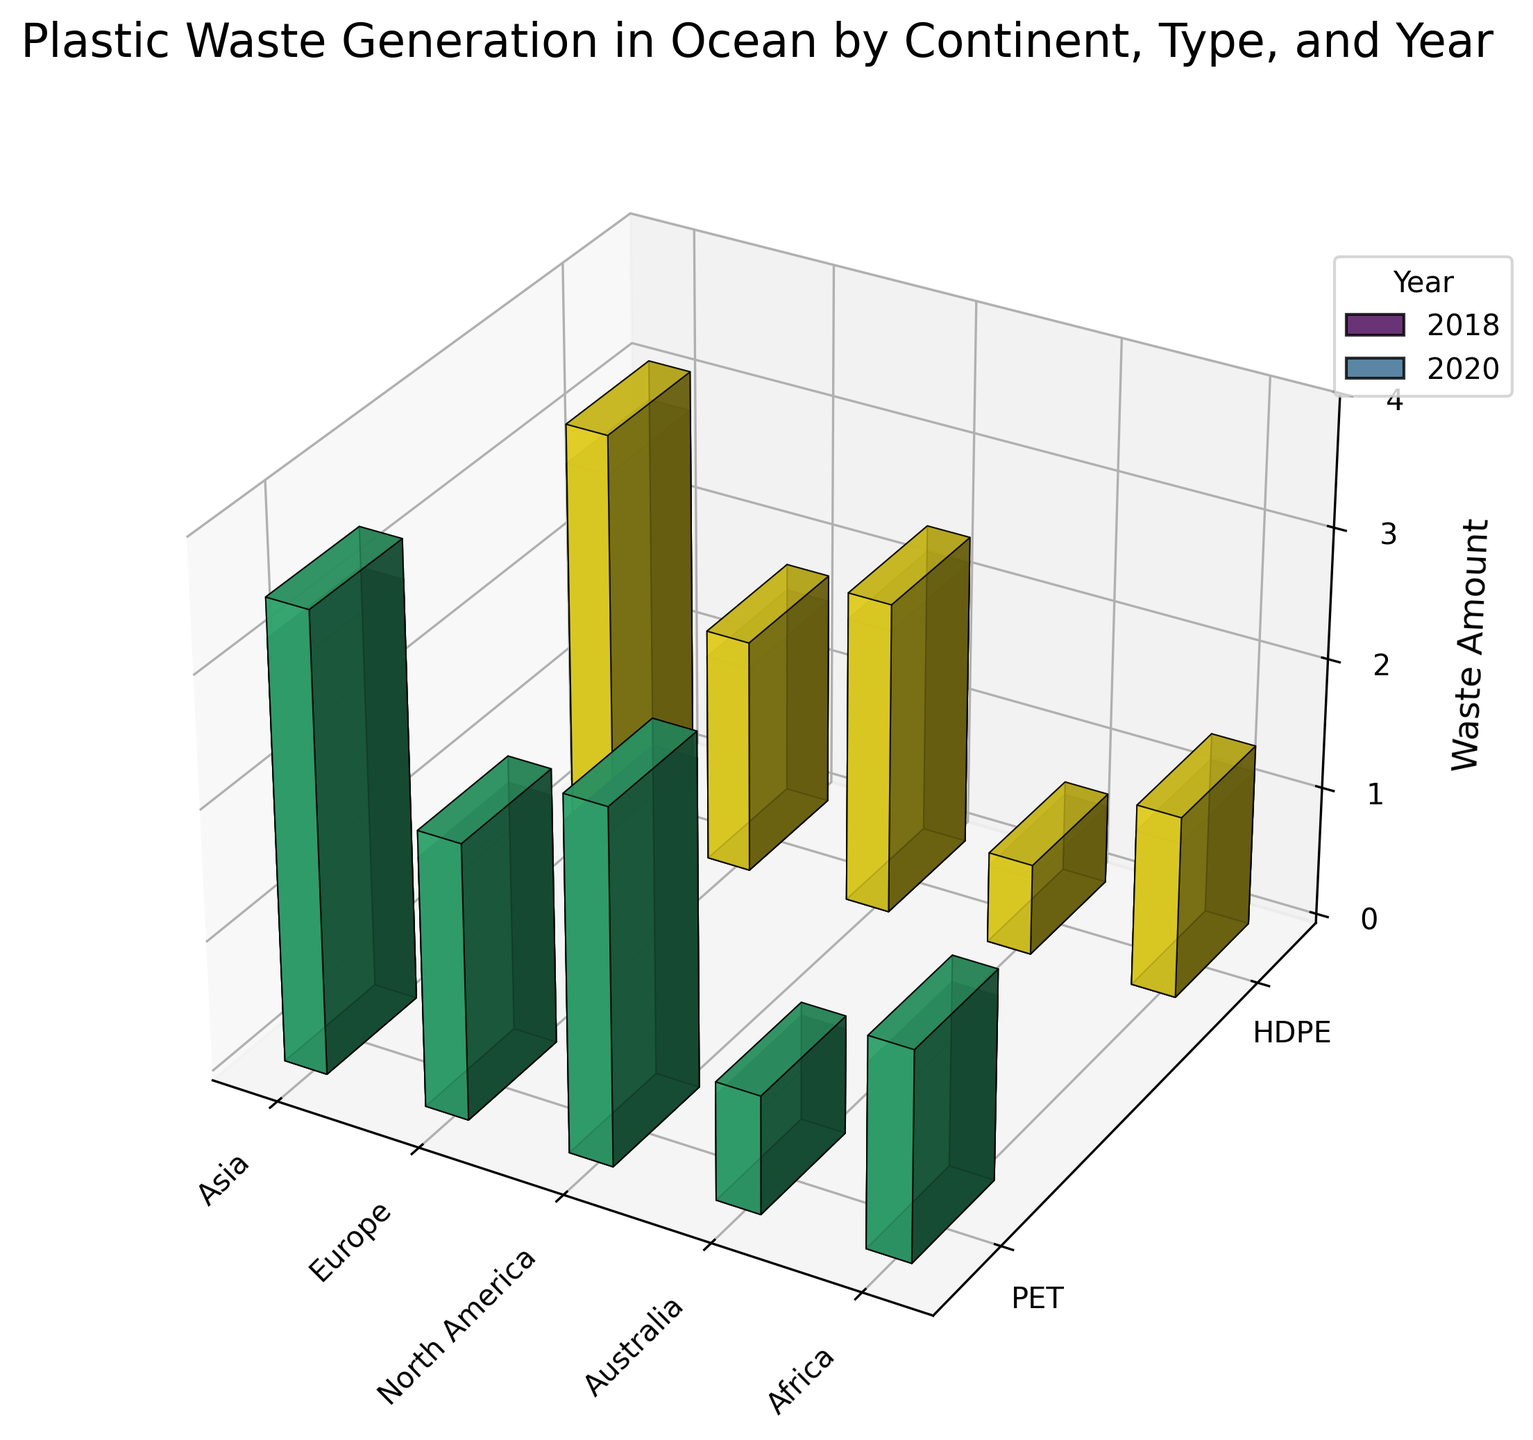What is the title of the plot? The title of the plot is located at the top center of the figure and reads "Plastic Waste Generation in Ocean by Continent, Type, and Year".
Answer: Plastic Waste Generation in Ocean by Continent, Type, and Year Which continent had the highest PET plastic waste generation in 2020? Look at the tallest bar associated with PET plastic for the year 2020. Asia has the tallest PET bar for 2020.
Answer: Asia How did the HDPE plastic waste amount in North America change from 2018 to 2020? Compare the height of the HDPE bars for North America between 2018 and 2020. The height increased from 2.2 in 2018 to 2.4 in 2020.
Answer: Increased What is the waste amount for PET plastic in Europe in 2018? Locate the bar that represents PET plastic in Europe for the year 2018. The height of this bar is 1.9.
Answer: 1.9 Which type of plastic saw an increase in waste amount in Africa from 2018 to 2020? Compare the heights of the PET and HDPE bars for Africa between 2018 and 2020. Both PET and HDPE increased from 1.4 and 1.2 to 1.6 and 1.4 respectively.
Answer: Both PET and HDPE Which continent had the lowest plastic waste generation for HDPE in 2018? Identify the shortest bar representing HDPE plastic in 2018. Australia has the shortest HDPE bar in 2018.
Answer: Australia What is the total plastic waste amount for both PET and HDPE in Australia in 2020? Add the heights of the PE and HDPE bars for Australia in 2020. The heights are 0.9 (PET) and 0.7 (HDPE), summing up to 1.6.
Answer: 1.6 Which continent saw the smallest change in PET plastic waste from 2018 to 2020? Compare the change in height of PET plastic bars between 2018 and 2020 for all continents. Australia's PET waste increased only from 0.8 to 0.9.
Answer: Australia How does Asia's PET plastic waste amount in 2020 compare to North America's PET plastic waste amount in 2020? Compare the bar heights of Asia's and North America's PET plastic waste for 2020. Asia's height is 3.5 while North America's is 2.7. Asia's amount is greater.
Answer: Asia's amount is greater 